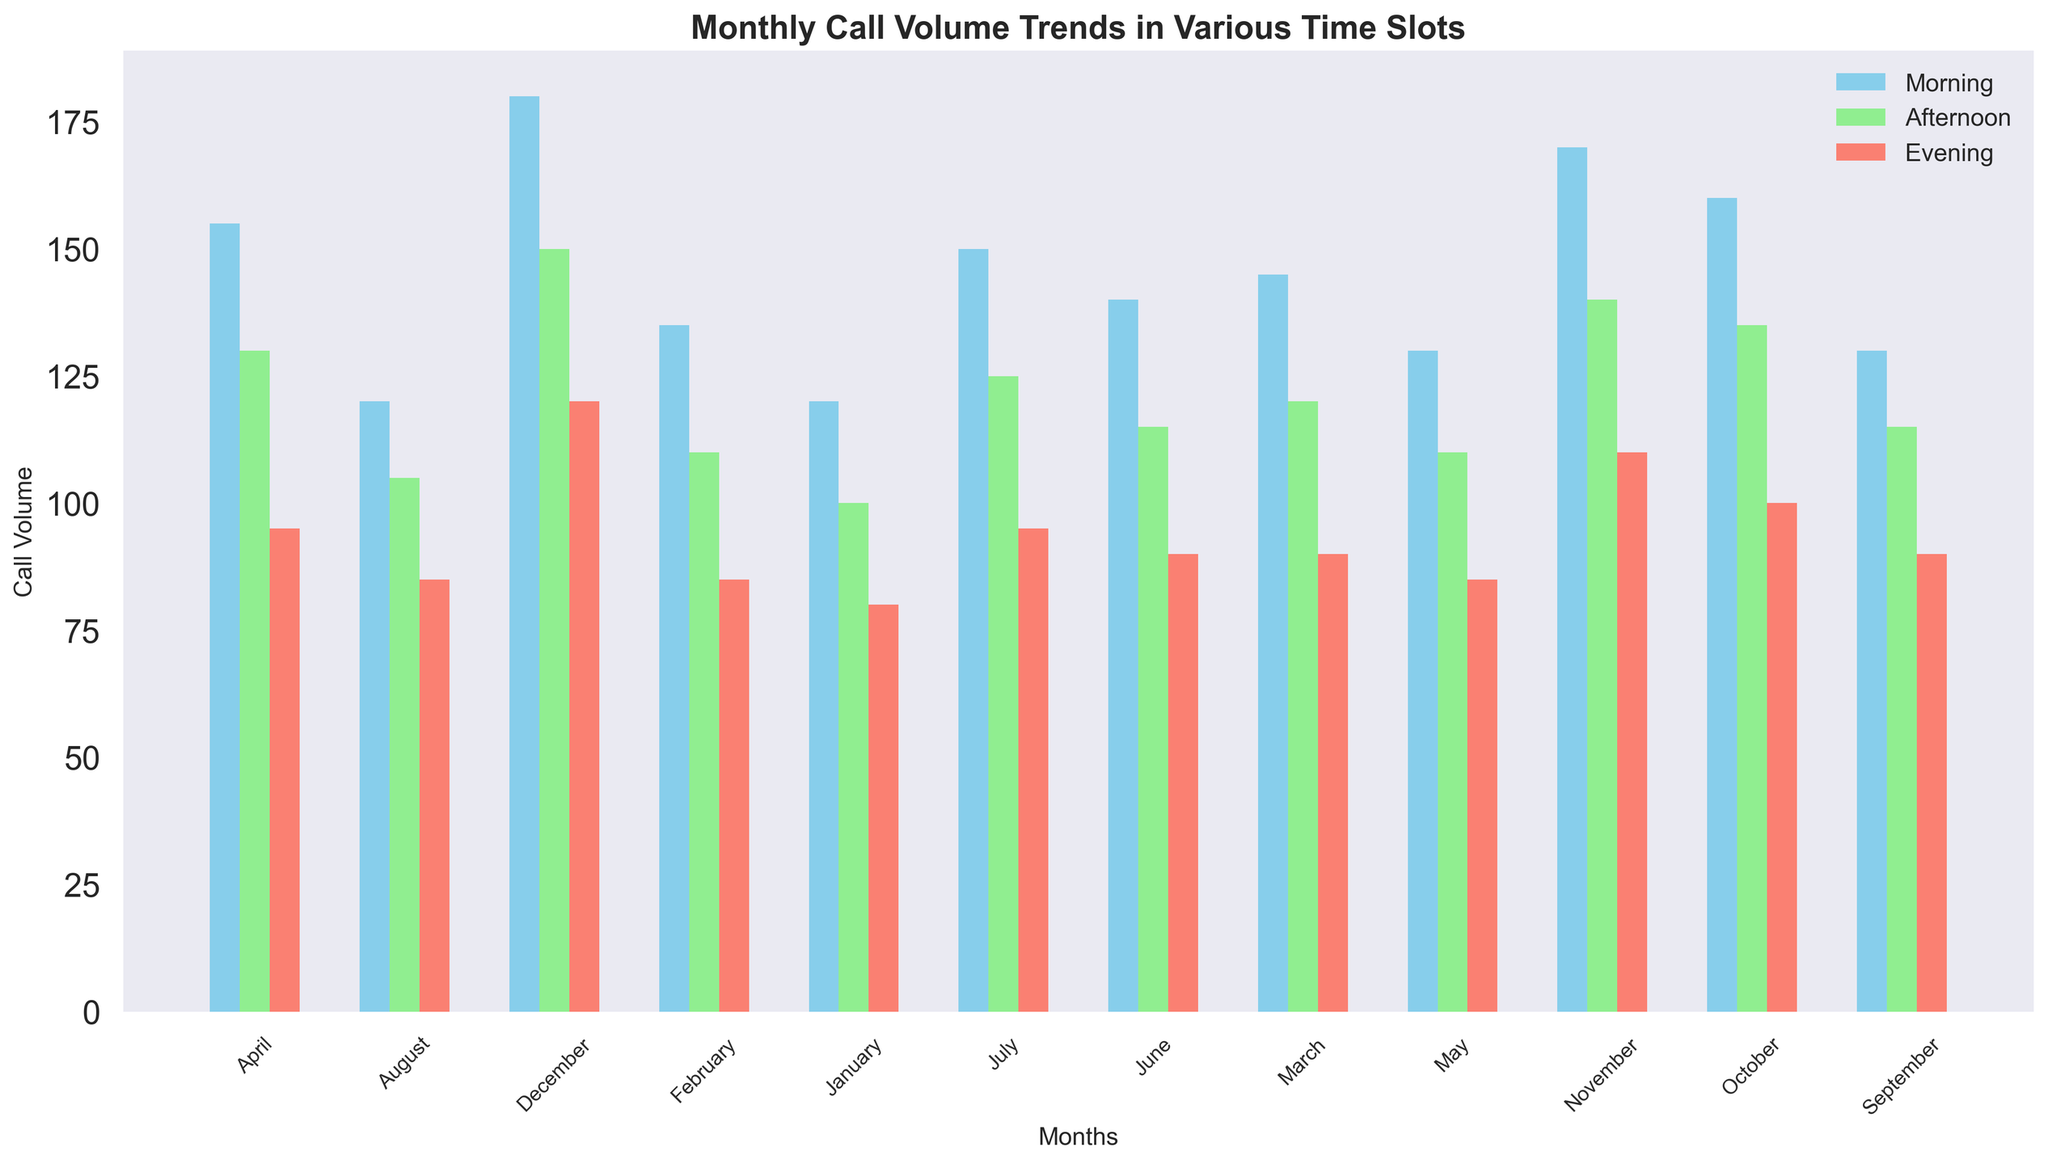Which month has the highest call volume in the morning? In the morning time slot, the bar for December is the tallest, indicating the highest call volume.
Answer: December Which time slot has the lowest call volume on average throughout the year? To find the average call volume for each time slot, sum the call volumes for all months and divide by 12. Calculating for Morning, Afternoon, and Evening, the Evening time slot has the lowest average call volume.
Answer: Evening What is the difference in call volume between the busiest and the least busy month in the afternoon? In the afternoon time slot, the highest call volume is in December (150) and the lowest is in August (105). The difference is 150 - 105.
Answer: 45 During which month is the call volume in the evening equal to the call volume in the afternoon? The bars for Evening and Afternoon in January both have the same height indicating an equal call volume of 80 and 100 respectively, so no month has equal call volumes.
Answer: None How does the call volume trend in the morning compare to the afternoon over the year? By visually comparing the bars month by month, the morning trend shows more dramatic increases and decreases, while the afternoon trend has more gradual changes.
Answer: Morning shows more dramatic changes What is the total call volume in May across all time slots? To find the total call volume, sum the call volumes for Morning (130), Afternoon (110), and Evening (85) in May. The total is 130 + 110 + 85.
Answer: 325 In which month does the evening time slot see its lowest call volume? The shortest bar in the Evening time slot corresponds to January and August, both with the lowest call volume of 85.
Answer: January and August Between which two consecutive months is the largest increase in morning call volume observed? By looking at the height difference between consecutive bars in the morning time slot, the largest increase is from September (130) to October (160).
Answer: September to October 